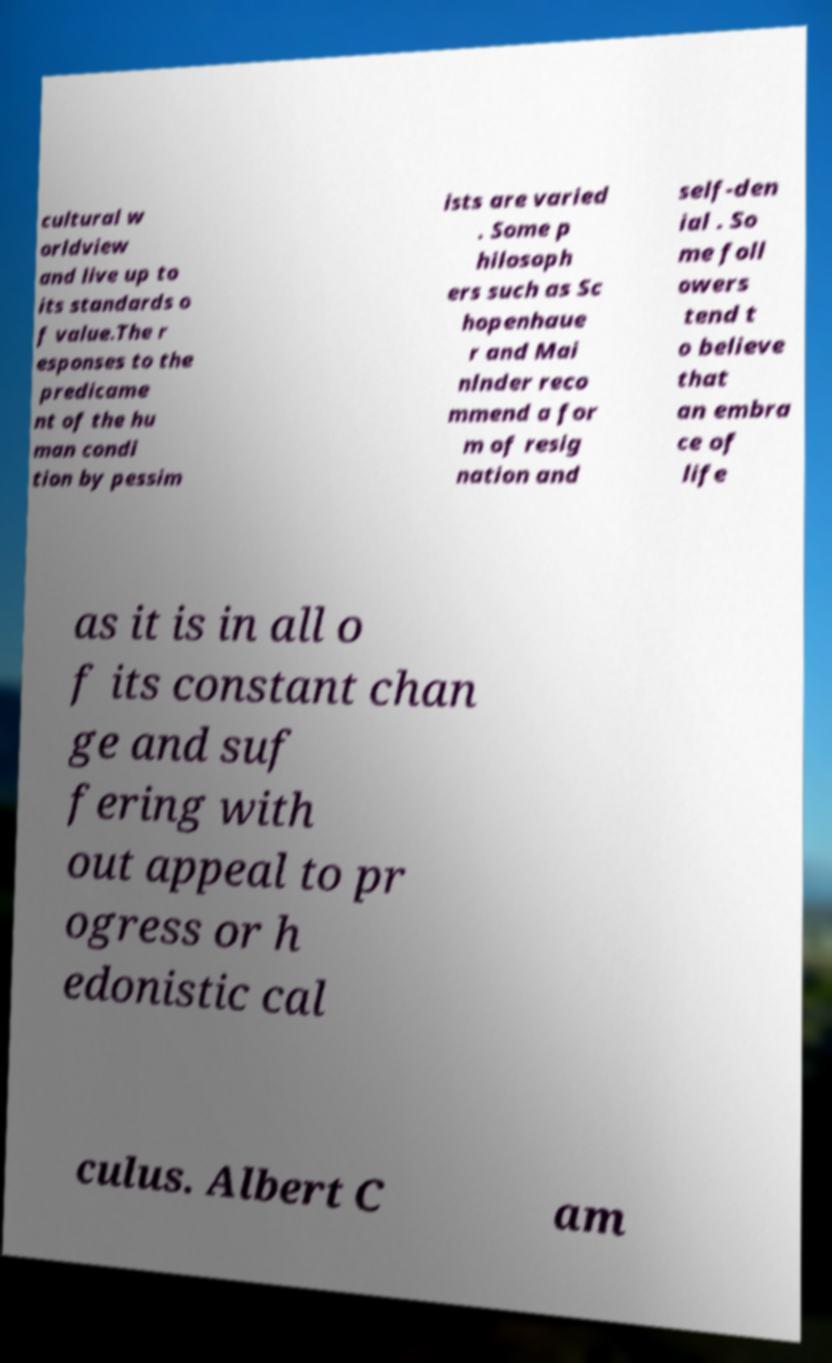Please identify and transcribe the text found in this image. cultural w orldview and live up to its standards o f value.The r esponses to the predicame nt of the hu man condi tion by pessim ists are varied . Some p hilosoph ers such as Sc hopenhaue r and Mai nlnder reco mmend a for m of resig nation and self-den ial . So me foll owers tend t o believe that an embra ce of life as it is in all o f its constant chan ge and suf fering with out appeal to pr ogress or h edonistic cal culus. Albert C am 